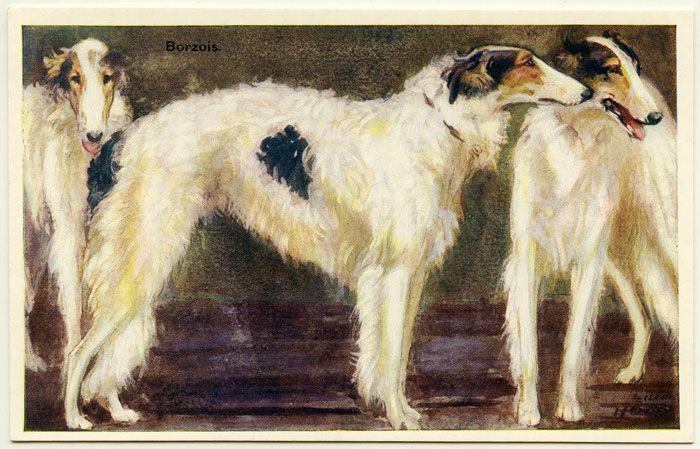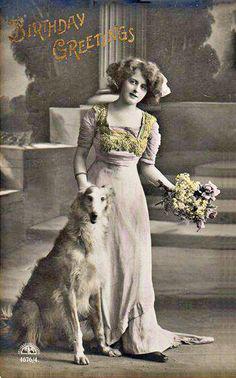The first image is the image on the left, the second image is the image on the right. Given the left and right images, does the statement "A woman is standing with a single dog in the image on the right." hold true? Answer yes or no. Yes. The first image is the image on the left, the second image is the image on the right. For the images shown, is this caption "The right image shows a woman in a long dress, standing behind an afghan hound, with flowers held in one hand." true? Answer yes or no. Yes. 